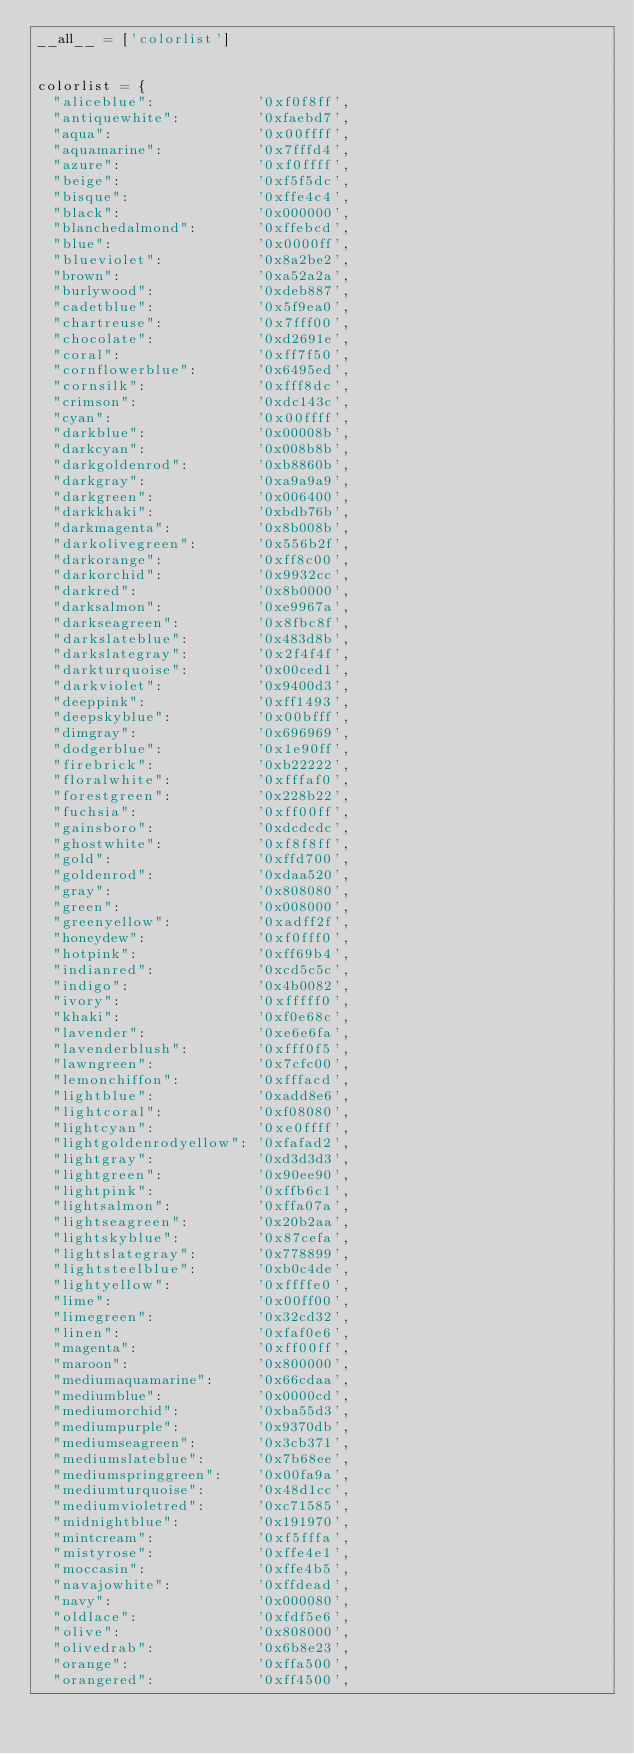Convert code to text. <code><loc_0><loc_0><loc_500><loc_500><_Python_>__all__ = ['colorlist']


colorlist = {
	"aliceblue":            '0xf0f8ff',
	"antiquewhite":         '0xfaebd7',
	"aqua":                 '0x00ffff',
	"aquamarine":           '0x7fffd4',
	"azure":                '0xf0ffff',
	"beige":                '0xf5f5dc',
	"bisque":               '0xffe4c4',
	"black":                '0x000000',
	"blanchedalmond":       '0xffebcd',
	"blue":                 '0x0000ff',
	"blueviolet":           '0x8a2be2',
	"brown":                '0xa52a2a',
	"burlywood":            '0xdeb887',
	"cadetblue":            '0x5f9ea0',
	"chartreuse":           '0x7fff00',
	"chocolate":            '0xd2691e',
	"coral":                '0xff7f50',
	"cornflowerblue":       '0x6495ed',
	"cornsilk":             '0xfff8dc',
	"crimson":              '0xdc143c',
	"cyan":                 '0x00ffff',
	"darkblue":             '0x00008b',
	"darkcyan":             '0x008b8b',
	"darkgoldenrod":        '0xb8860b',
	"darkgray":             '0xa9a9a9',
	"darkgreen":            '0x006400',
	"darkkhaki":            '0xbdb76b',
	"darkmagenta":          '0x8b008b',
	"darkolivegreen":       '0x556b2f',
	"darkorange":           '0xff8c00',
	"darkorchid":           '0x9932cc',
	"darkred":              '0x8b0000',
	"darksalmon":           '0xe9967a',
	"darkseagreen":         '0x8fbc8f',
	"darkslateblue":        '0x483d8b',
	"darkslategray":        '0x2f4f4f',
	"darkturquoise":        '0x00ced1',
	"darkviolet":           '0x9400d3',
	"deeppink":             '0xff1493',
	"deepskyblue":          '0x00bfff',
	"dimgray":              '0x696969',
	"dodgerblue":           '0x1e90ff',
	"firebrick":            '0xb22222',
	"floralwhite":          '0xfffaf0',
	"forestgreen":          '0x228b22',
	"fuchsia":              '0xff00ff',
	"gainsboro":            '0xdcdcdc',
	"ghostwhite":           '0xf8f8ff',
	"gold":                 '0xffd700',
	"goldenrod":            '0xdaa520',
	"gray":                 '0x808080',
	"green":                '0x008000',
	"greenyellow":          '0xadff2f',
	"honeydew":             '0xf0fff0',
	"hotpink":              '0xff69b4',
	"indianred":            '0xcd5c5c',
	"indigo":               '0x4b0082',
	"ivory":                '0xfffff0',
	"khaki":                '0xf0e68c',
	"lavender":             '0xe6e6fa',
	"lavenderblush":        '0xfff0f5',
	"lawngreen":            '0x7cfc00',
	"lemonchiffon":         '0xfffacd',
	"lightblue":            '0xadd8e6',
	"lightcoral":           '0xf08080',
	"lightcyan":            '0xe0ffff',
	"lightgoldenrodyellow": '0xfafad2',
	"lightgray":            '0xd3d3d3',
	"lightgreen":           '0x90ee90',
	"lightpink":            '0xffb6c1',
	"lightsalmon":          '0xffa07a',
	"lightseagreen":        '0x20b2aa',
	"lightskyblue":         '0x87cefa',
	"lightslategray":       '0x778899',
	"lightsteelblue":       '0xb0c4de',
	"lightyellow":          '0xffffe0',
	"lime":                 '0x00ff00',
	"limegreen":            '0x32cd32',
	"linen":                '0xfaf0e6',
	"magenta":              '0xff00ff',
	"maroon":               '0x800000',
	"mediumaquamarine":     '0x66cdaa',
	"mediumblue":           '0x0000cd',
	"mediumorchid":         '0xba55d3',
	"mediumpurple":         '0x9370db',
	"mediumseagreen":       '0x3cb371',
	"mediumslateblue":      '0x7b68ee',
	"mediumspringgreen":    '0x00fa9a',
	"mediumturquoise":      '0x48d1cc',
	"mediumvioletred":      '0xc71585',
	"midnightblue":         '0x191970',
	"mintcream":            '0xf5fffa',
	"mistyrose":            '0xffe4e1',
	"moccasin":             '0xffe4b5',
	"navajowhite":          '0xffdead',
	"navy":                 '0x000080',
	"oldlace":              '0xfdf5e6',
	"olive":                '0x808000',
	"olivedrab":            '0x6b8e23',
	"orange":               '0xffa500',
	"orangered":            '0xff4500',</code> 